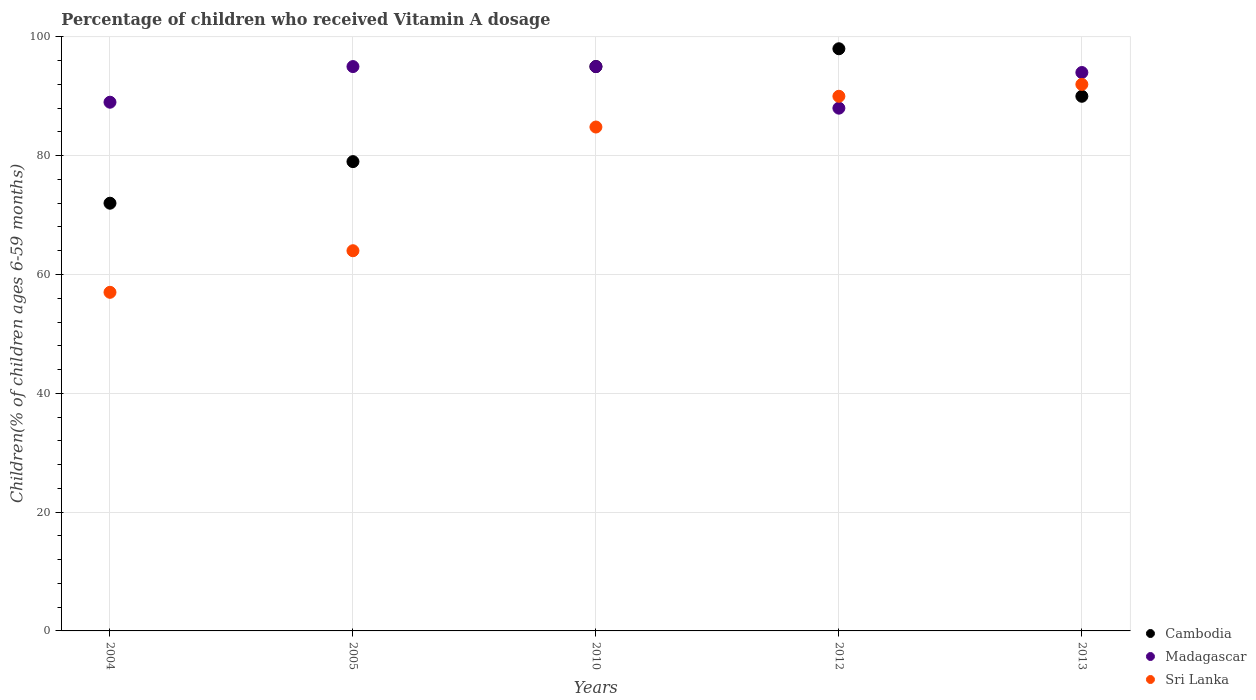Is the number of dotlines equal to the number of legend labels?
Offer a terse response. Yes. What is the percentage of children who received Vitamin A dosage in Cambodia in 2010?
Provide a succinct answer. 95. Across all years, what is the minimum percentage of children who received Vitamin A dosage in Sri Lanka?
Provide a succinct answer. 57. In which year was the percentage of children who received Vitamin A dosage in Madagascar maximum?
Your answer should be very brief. 2005. In which year was the percentage of children who received Vitamin A dosage in Madagascar minimum?
Ensure brevity in your answer.  2012. What is the total percentage of children who received Vitamin A dosage in Cambodia in the graph?
Your answer should be compact. 434. What is the difference between the percentage of children who received Vitamin A dosage in Cambodia in 2013 and the percentage of children who received Vitamin A dosage in Madagascar in 2012?
Provide a short and direct response. 2. What is the average percentage of children who received Vitamin A dosage in Madagascar per year?
Your answer should be compact. 92.2. In how many years, is the percentage of children who received Vitamin A dosage in Cambodia greater than 96 %?
Your answer should be compact. 1. What is the ratio of the percentage of children who received Vitamin A dosage in Cambodia in 2005 to that in 2010?
Your answer should be very brief. 0.83. What is the difference between the highest and the second highest percentage of children who received Vitamin A dosage in Cambodia?
Give a very brief answer. 3. What is the difference between the highest and the lowest percentage of children who received Vitamin A dosage in Madagascar?
Offer a terse response. 7. Is the sum of the percentage of children who received Vitamin A dosage in Cambodia in 2004 and 2013 greater than the maximum percentage of children who received Vitamin A dosage in Madagascar across all years?
Provide a short and direct response. Yes. Does the percentage of children who received Vitamin A dosage in Madagascar monotonically increase over the years?
Give a very brief answer. No. Is the percentage of children who received Vitamin A dosage in Cambodia strictly less than the percentage of children who received Vitamin A dosage in Sri Lanka over the years?
Your answer should be compact. No. How many dotlines are there?
Your response must be concise. 3. How many years are there in the graph?
Your answer should be very brief. 5. What is the difference between two consecutive major ticks on the Y-axis?
Your answer should be compact. 20. Does the graph contain any zero values?
Your answer should be compact. No. Where does the legend appear in the graph?
Your response must be concise. Bottom right. What is the title of the graph?
Provide a short and direct response. Percentage of children who received Vitamin A dosage. Does "St. Lucia" appear as one of the legend labels in the graph?
Make the answer very short. No. What is the label or title of the X-axis?
Offer a very short reply. Years. What is the label or title of the Y-axis?
Your response must be concise. Children(% of children ages 6-59 months). What is the Children(% of children ages 6-59 months) of Madagascar in 2004?
Provide a succinct answer. 89. What is the Children(% of children ages 6-59 months) of Cambodia in 2005?
Provide a succinct answer. 79. What is the Children(% of children ages 6-59 months) of Madagascar in 2005?
Offer a very short reply. 95. What is the Children(% of children ages 6-59 months) in Sri Lanka in 2005?
Ensure brevity in your answer.  64. What is the Children(% of children ages 6-59 months) in Sri Lanka in 2010?
Make the answer very short. 84.82. What is the Children(% of children ages 6-59 months) in Cambodia in 2013?
Ensure brevity in your answer.  90. What is the Children(% of children ages 6-59 months) in Madagascar in 2013?
Your response must be concise. 94. What is the Children(% of children ages 6-59 months) in Sri Lanka in 2013?
Make the answer very short. 92. Across all years, what is the maximum Children(% of children ages 6-59 months) of Cambodia?
Give a very brief answer. 98. Across all years, what is the maximum Children(% of children ages 6-59 months) of Madagascar?
Provide a succinct answer. 95. Across all years, what is the maximum Children(% of children ages 6-59 months) of Sri Lanka?
Provide a succinct answer. 92. What is the total Children(% of children ages 6-59 months) of Cambodia in the graph?
Ensure brevity in your answer.  434. What is the total Children(% of children ages 6-59 months) in Madagascar in the graph?
Your answer should be very brief. 461. What is the total Children(% of children ages 6-59 months) in Sri Lanka in the graph?
Make the answer very short. 387.82. What is the difference between the Children(% of children ages 6-59 months) in Cambodia in 2004 and that in 2005?
Your answer should be very brief. -7. What is the difference between the Children(% of children ages 6-59 months) of Sri Lanka in 2004 and that in 2005?
Ensure brevity in your answer.  -7. What is the difference between the Children(% of children ages 6-59 months) of Cambodia in 2004 and that in 2010?
Keep it short and to the point. -23. What is the difference between the Children(% of children ages 6-59 months) in Madagascar in 2004 and that in 2010?
Your answer should be very brief. -6. What is the difference between the Children(% of children ages 6-59 months) in Sri Lanka in 2004 and that in 2010?
Provide a succinct answer. -27.82. What is the difference between the Children(% of children ages 6-59 months) in Madagascar in 2004 and that in 2012?
Your answer should be very brief. 1. What is the difference between the Children(% of children ages 6-59 months) of Sri Lanka in 2004 and that in 2012?
Provide a succinct answer. -33. What is the difference between the Children(% of children ages 6-59 months) in Cambodia in 2004 and that in 2013?
Keep it short and to the point. -18. What is the difference between the Children(% of children ages 6-59 months) in Sri Lanka in 2004 and that in 2013?
Your response must be concise. -35. What is the difference between the Children(% of children ages 6-59 months) of Cambodia in 2005 and that in 2010?
Your answer should be compact. -16. What is the difference between the Children(% of children ages 6-59 months) in Madagascar in 2005 and that in 2010?
Give a very brief answer. 0. What is the difference between the Children(% of children ages 6-59 months) of Sri Lanka in 2005 and that in 2010?
Make the answer very short. -20.82. What is the difference between the Children(% of children ages 6-59 months) of Madagascar in 2005 and that in 2012?
Provide a short and direct response. 7. What is the difference between the Children(% of children ages 6-59 months) of Cambodia in 2005 and that in 2013?
Offer a terse response. -11. What is the difference between the Children(% of children ages 6-59 months) of Madagascar in 2010 and that in 2012?
Your answer should be compact. 7. What is the difference between the Children(% of children ages 6-59 months) of Sri Lanka in 2010 and that in 2012?
Your answer should be very brief. -5.18. What is the difference between the Children(% of children ages 6-59 months) of Madagascar in 2010 and that in 2013?
Provide a short and direct response. 1. What is the difference between the Children(% of children ages 6-59 months) in Sri Lanka in 2010 and that in 2013?
Provide a short and direct response. -7.18. What is the difference between the Children(% of children ages 6-59 months) of Sri Lanka in 2012 and that in 2013?
Provide a succinct answer. -2. What is the difference between the Children(% of children ages 6-59 months) of Cambodia in 2004 and the Children(% of children ages 6-59 months) of Madagascar in 2005?
Ensure brevity in your answer.  -23. What is the difference between the Children(% of children ages 6-59 months) of Cambodia in 2004 and the Children(% of children ages 6-59 months) of Sri Lanka in 2005?
Provide a succinct answer. 8. What is the difference between the Children(% of children ages 6-59 months) in Cambodia in 2004 and the Children(% of children ages 6-59 months) in Sri Lanka in 2010?
Give a very brief answer. -12.82. What is the difference between the Children(% of children ages 6-59 months) in Madagascar in 2004 and the Children(% of children ages 6-59 months) in Sri Lanka in 2010?
Your response must be concise. 4.18. What is the difference between the Children(% of children ages 6-59 months) in Cambodia in 2004 and the Children(% of children ages 6-59 months) in Sri Lanka in 2012?
Make the answer very short. -18. What is the difference between the Children(% of children ages 6-59 months) of Cambodia in 2004 and the Children(% of children ages 6-59 months) of Sri Lanka in 2013?
Your response must be concise. -20. What is the difference between the Children(% of children ages 6-59 months) in Madagascar in 2004 and the Children(% of children ages 6-59 months) in Sri Lanka in 2013?
Offer a terse response. -3. What is the difference between the Children(% of children ages 6-59 months) of Cambodia in 2005 and the Children(% of children ages 6-59 months) of Madagascar in 2010?
Keep it short and to the point. -16. What is the difference between the Children(% of children ages 6-59 months) of Cambodia in 2005 and the Children(% of children ages 6-59 months) of Sri Lanka in 2010?
Your answer should be very brief. -5.82. What is the difference between the Children(% of children ages 6-59 months) in Madagascar in 2005 and the Children(% of children ages 6-59 months) in Sri Lanka in 2010?
Your answer should be very brief. 10.18. What is the difference between the Children(% of children ages 6-59 months) in Cambodia in 2005 and the Children(% of children ages 6-59 months) in Sri Lanka in 2012?
Your answer should be very brief. -11. What is the difference between the Children(% of children ages 6-59 months) in Madagascar in 2005 and the Children(% of children ages 6-59 months) in Sri Lanka in 2012?
Give a very brief answer. 5. What is the difference between the Children(% of children ages 6-59 months) of Cambodia in 2005 and the Children(% of children ages 6-59 months) of Madagascar in 2013?
Your answer should be very brief. -15. What is the difference between the Children(% of children ages 6-59 months) of Madagascar in 2005 and the Children(% of children ages 6-59 months) of Sri Lanka in 2013?
Keep it short and to the point. 3. What is the difference between the Children(% of children ages 6-59 months) of Cambodia in 2010 and the Children(% of children ages 6-59 months) of Madagascar in 2012?
Your response must be concise. 7. What is the difference between the Children(% of children ages 6-59 months) of Madagascar in 2010 and the Children(% of children ages 6-59 months) of Sri Lanka in 2012?
Provide a succinct answer. 5. What is the difference between the Children(% of children ages 6-59 months) of Madagascar in 2010 and the Children(% of children ages 6-59 months) of Sri Lanka in 2013?
Your response must be concise. 3. What is the difference between the Children(% of children ages 6-59 months) in Cambodia in 2012 and the Children(% of children ages 6-59 months) in Madagascar in 2013?
Your response must be concise. 4. What is the difference between the Children(% of children ages 6-59 months) in Cambodia in 2012 and the Children(% of children ages 6-59 months) in Sri Lanka in 2013?
Give a very brief answer. 6. What is the difference between the Children(% of children ages 6-59 months) in Madagascar in 2012 and the Children(% of children ages 6-59 months) in Sri Lanka in 2013?
Offer a very short reply. -4. What is the average Children(% of children ages 6-59 months) in Cambodia per year?
Your answer should be compact. 86.8. What is the average Children(% of children ages 6-59 months) in Madagascar per year?
Ensure brevity in your answer.  92.2. What is the average Children(% of children ages 6-59 months) in Sri Lanka per year?
Your answer should be very brief. 77.56. In the year 2004, what is the difference between the Children(% of children ages 6-59 months) in Cambodia and Children(% of children ages 6-59 months) in Madagascar?
Provide a short and direct response. -17. In the year 2004, what is the difference between the Children(% of children ages 6-59 months) in Cambodia and Children(% of children ages 6-59 months) in Sri Lanka?
Make the answer very short. 15. In the year 2004, what is the difference between the Children(% of children ages 6-59 months) in Madagascar and Children(% of children ages 6-59 months) in Sri Lanka?
Make the answer very short. 32. In the year 2010, what is the difference between the Children(% of children ages 6-59 months) of Cambodia and Children(% of children ages 6-59 months) of Madagascar?
Offer a very short reply. 0. In the year 2010, what is the difference between the Children(% of children ages 6-59 months) of Cambodia and Children(% of children ages 6-59 months) of Sri Lanka?
Provide a short and direct response. 10.18. In the year 2010, what is the difference between the Children(% of children ages 6-59 months) of Madagascar and Children(% of children ages 6-59 months) of Sri Lanka?
Make the answer very short. 10.18. In the year 2013, what is the difference between the Children(% of children ages 6-59 months) in Madagascar and Children(% of children ages 6-59 months) in Sri Lanka?
Offer a very short reply. 2. What is the ratio of the Children(% of children ages 6-59 months) of Cambodia in 2004 to that in 2005?
Your answer should be very brief. 0.91. What is the ratio of the Children(% of children ages 6-59 months) of Madagascar in 2004 to that in 2005?
Offer a very short reply. 0.94. What is the ratio of the Children(% of children ages 6-59 months) of Sri Lanka in 2004 to that in 2005?
Your answer should be very brief. 0.89. What is the ratio of the Children(% of children ages 6-59 months) in Cambodia in 2004 to that in 2010?
Provide a short and direct response. 0.76. What is the ratio of the Children(% of children ages 6-59 months) of Madagascar in 2004 to that in 2010?
Offer a terse response. 0.94. What is the ratio of the Children(% of children ages 6-59 months) in Sri Lanka in 2004 to that in 2010?
Ensure brevity in your answer.  0.67. What is the ratio of the Children(% of children ages 6-59 months) in Cambodia in 2004 to that in 2012?
Your response must be concise. 0.73. What is the ratio of the Children(% of children ages 6-59 months) in Madagascar in 2004 to that in 2012?
Offer a very short reply. 1.01. What is the ratio of the Children(% of children ages 6-59 months) in Sri Lanka in 2004 to that in 2012?
Ensure brevity in your answer.  0.63. What is the ratio of the Children(% of children ages 6-59 months) in Madagascar in 2004 to that in 2013?
Your response must be concise. 0.95. What is the ratio of the Children(% of children ages 6-59 months) of Sri Lanka in 2004 to that in 2013?
Give a very brief answer. 0.62. What is the ratio of the Children(% of children ages 6-59 months) in Cambodia in 2005 to that in 2010?
Your answer should be compact. 0.83. What is the ratio of the Children(% of children ages 6-59 months) of Sri Lanka in 2005 to that in 2010?
Give a very brief answer. 0.75. What is the ratio of the Children(% of children ages 6-59 months) in Cambodia in 2005 to that in 2012?
Make the answer very short. 0.81. What is the ratio of the Children(% of children ages 6-59 months) in Madagascar in 2005 to that in 2012?
Provide a succinct answer. 1.08. What is the ratio of the Children(% of children ages 6-59 months) in Sri Lanka in 2005 to that in 2012?
Provide a short and direct response. 0.71. What is the ratio of the Children(% of children ages 6-59 months) of Cambodia in 2005 to that in 2013?
Provide a succinct answer. 0.88. What is the ratio of the Children(% of children ages 6-59 months) in Madagascar in 2005 to that in 2013?
Your answer should be very brief. 1.01. What is the ratio of the Children(% of children ages 6-59 months) in Sri Lanka in 2005 to that in 2013?
Offer a very short reply. 0.7. What is the ratio of the Children(% of children ages 6-59 months) of Cambodia in 2010 to that in 2012?
Give a very brief answer. 0.97. What is the ratio of the Children(% of children ages 6-59 months) of Madagascar in 2010 to that in 2012?
Keep it short and to the point. 1.08. What is the ratio of the Children(% of children ages 6-59 months) of Sri Lanka in 2010 to that in 2012?
Provide a short and direct response. 0.94. What is the ratio of the Children(% of children ages 6-59 months) of Cambodia in 2010 to that in 2013?
Keep it short and to the point. 1.06. What is the ratio of the Children(% of children ages 6-59 months) of Madagascar in 2010 to that in 2013?
Offer a terse response. 1.01. What is the ratio of the Children(% of children ages 6-59 months) in Sri Lanka in 2010 to that in 2013?
Ensure brevity in your answer.  0.92. What is the ratio of the Children(% of children ages 6-59 months) of Cambodia in 2012 to that in 2013?
Provide a succinct answer. 1.09. What is the ratio of the Children(% of children ages 6-59 months) of Madagascar in 2012 to that in 2013?
Your answer should be compact. 0.94. What is the ratio of the Children(% of children ages 6-59 months) in Sri Lanka in 2012 to that in 2013?
Give a very brief answer. 0.98. What is the difference between the highest and the second highest Children(% of children ages 6-59 months) in Cambodia?
Make the answer very short. 3. What is the difference between the highest and the second highest Children(% of children ages 6-59 months) of Madagascar?
Keep it short and to the point. 0. What is the difference between the highest and the lowest Children(% of children ages 6-59 months) in Madagascar?
Your response must be concise. 7. 